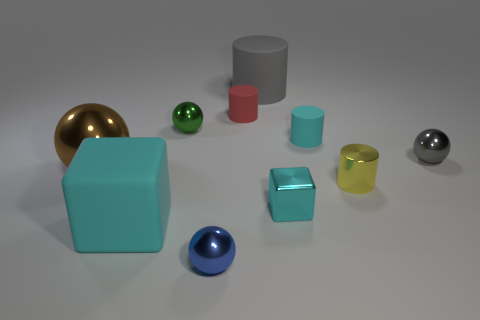How do the shadows in the image inform us about the light source? The shadows cast by the objects in the image are soft and extend to the right, indicating that the light source is not only soft but also located to the upper left of the scene. Could you determine the time of day if this was an outdoor scene? If this were an outdoor scene, the angle and softness of the shadows might suggest it's either morning or late afternoon, when the sun is lower in the sky, but without context, we cannot accurately determine the time of day. 